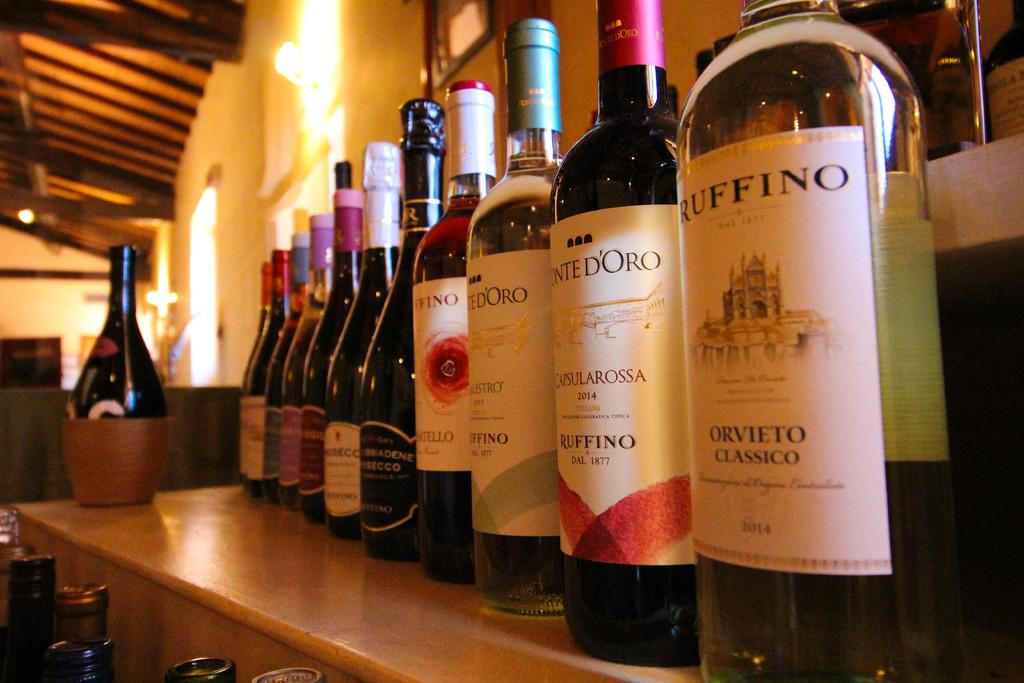<image>
Write a terse but informative summary of the picture. A wine display has a bottle of Orvieto Classico from 2014. 